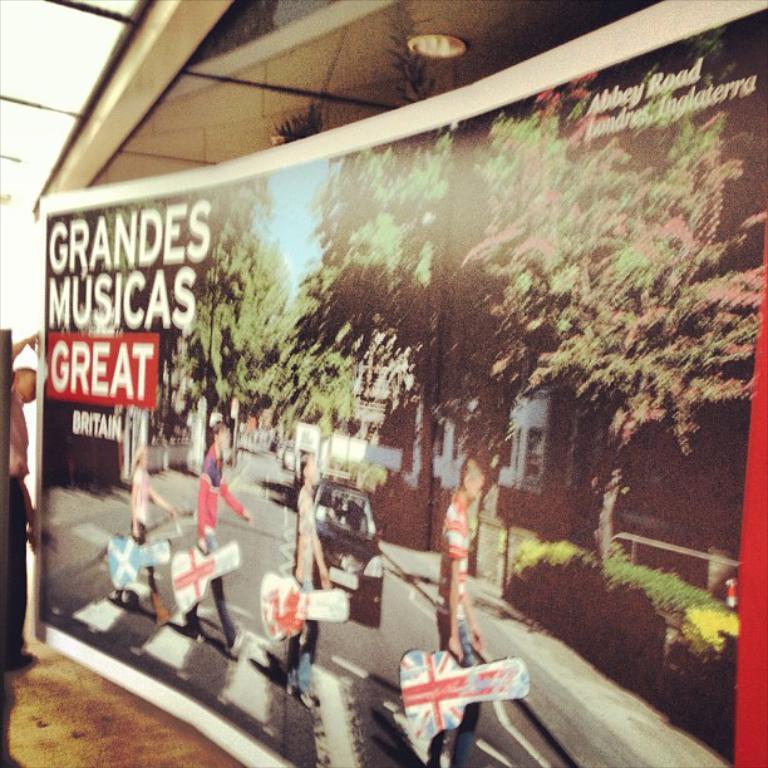Could you give a brief overview of what you see in this image? In this picture I can see a man is holding a board. In the picture of a board I can see people are holding bags. I can also see a car on the road, trees, house and sky. I can also see something written on the board. In the background I can see ceiling. 